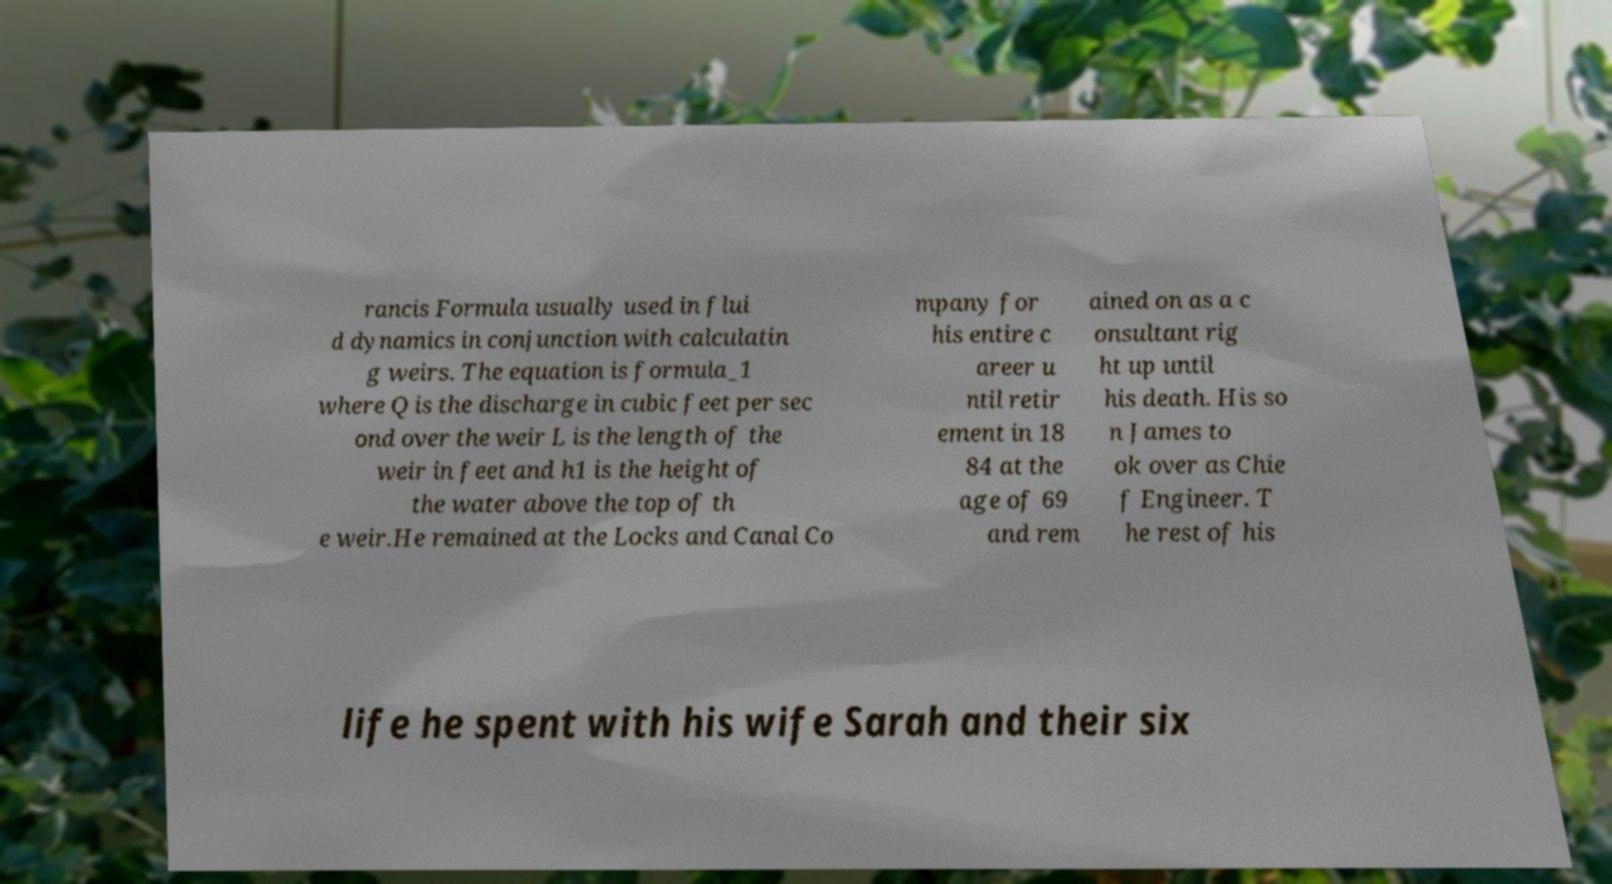What messages or text are displayed in this image? I need them in a readable, typed format. rancis Formula usually used in flui d dynamics in conjunction with calculatin g weirs. The equation is formula_1 where Q is the discharge in cubic feet per sec ond over the weir L is the length of the weir in feet and h1 is the height of the water above the top of th e weir.He remained at the Locks and Canal Co mpany for his entire c areer u ntil retir ement in 18 84 at the age of 69 and rem ained on as a c onsultant rig ht up until his death. His so n James to ok over as Chie f Engineer. T he rest of his life he spent with his wife Sarah and their six 